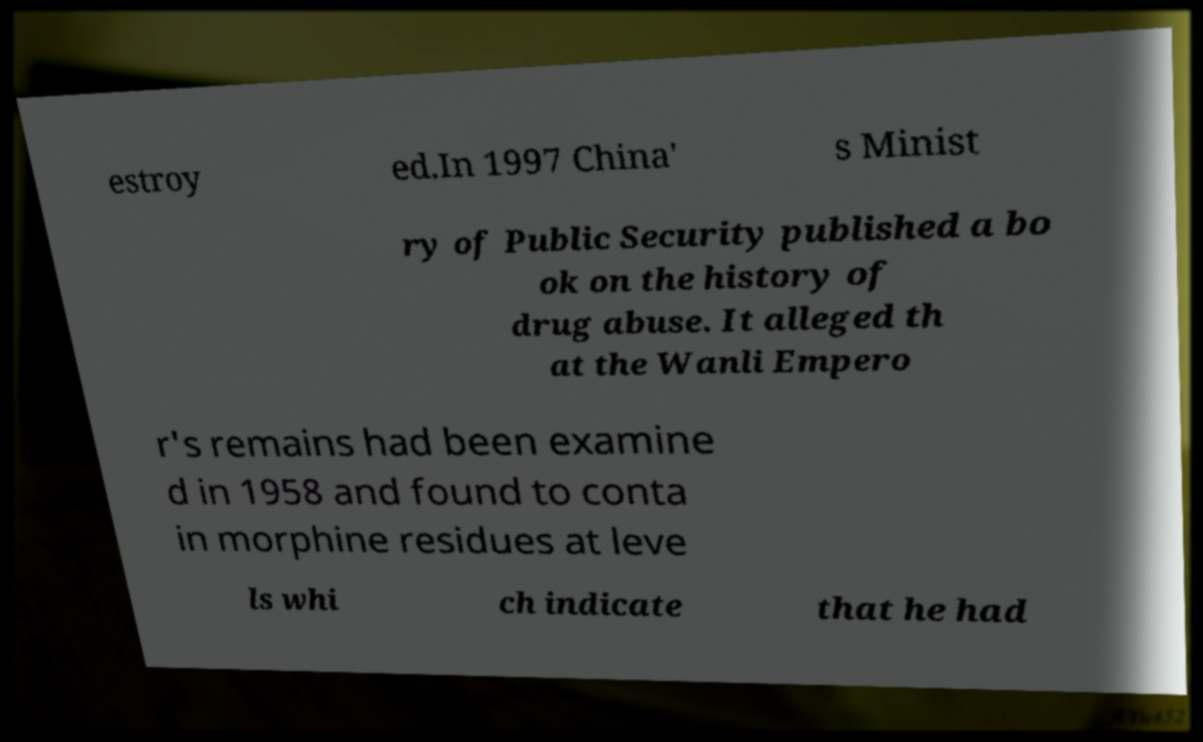For documentation purposes, I need the text within this image transcribed. Could you provide that? estroy ed.In 1997 China' s Minist ry of Public Security published a bo ok on the history of drug abuse. It alleged th at the Wanli Empero r's remains had been examine d in 1958 and found to conta in morphine residues at leve ls whi ch indicate that he had 